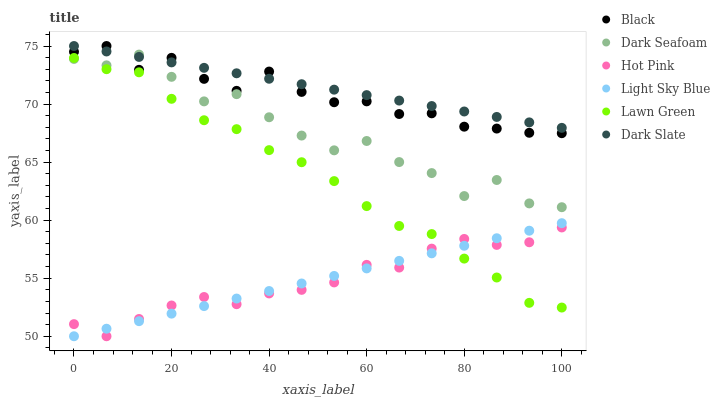Does Hot Pink have the minimum area under the curve?
Answer yes or no. Yes. Does Dark Slate have the maximum area under the curve?
Answer yes or no. Yes. Does Dark Slate have the minimum area under the curve?
Answer yes or no. No. Does Hot Pink have the maximum area under the curve?
Answer yes or no. No. Is Dark Slate the smoothest?
Answer yes or no. Yes. Is Dark Seafoam the roughest?
Answer yes or no. Yes. Is Hot Pink the smoothest?
Answer yes or no. No. Is Hot Pink the roughest?
Answer yes or no. No. Does Hot Pink have the lowest value?
Answer yes or no. Yes. Does Dark Slate have the lowest value?
Answer yes or no. No. Does Black have the highest value?
Answer yes or no. Yes. Does Hot Pink have the highest value?
Answer yes or no. No. Is Lawn Green less than Dark Slate?
Answer yes or no. Yes. Is Black greater than Light Sky Blue?
Answer yes or no. Yes. Does Lawn Green intersect Hot Pink?
Answer yes or no. Yes. Is Lawn Green less than Hot Pink?
Answer yes or no. No. Is Lawn Green greater than Hot Pink?
Answer yes or no. No. Does Lawn Green intersect Dark Slate?
Answer yes or no. No. 